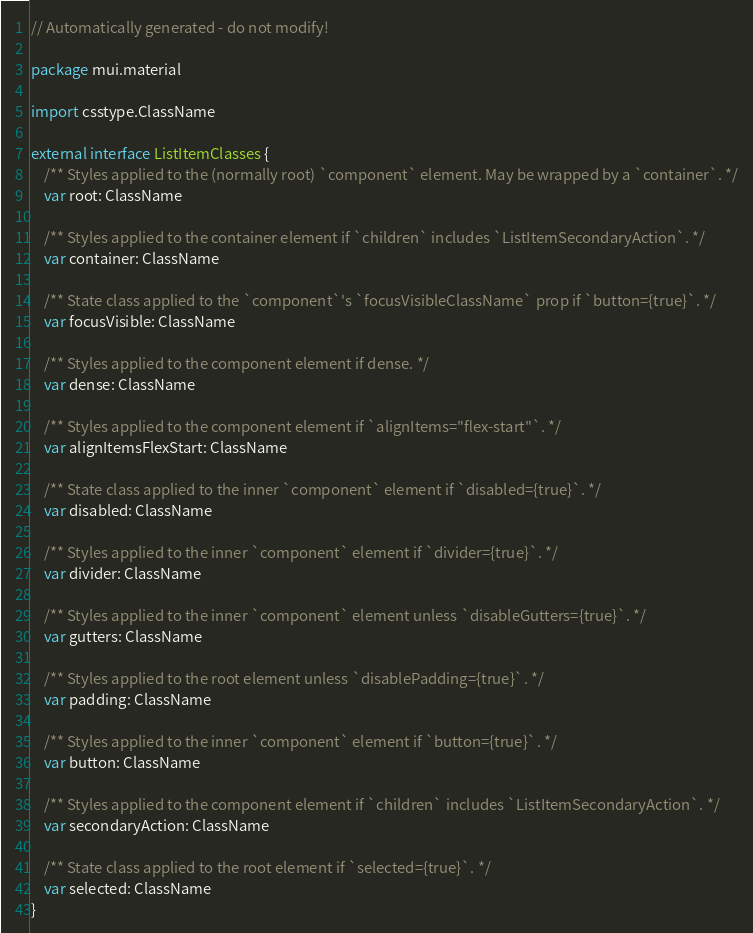Convert code to text. <code><loc_0><loc_0><loc_500><loc_500><_Kotlin_>// Automatically generated - do not modify!

package mui.material

import csstype.ClassName

external interface ListItemClasses {
    /** Styles applied to the (normally root) `component` element. May be wrapped by a `container`. */
    var root: ClassName

    /** Styles applied to the container element if `children` includes `ListItemSecondaryAction`. */
    var container: ClassName

    /** State class applied to the `component`'s `focusVisibleClassName` prop if `button={true}`. */
    var focusVisible: ClassName

    /** Styles applied to the component element if dense. */
    var dense: ClassName

    /** Styles applied to the component element if `alignItems="flex-start"`. */
    var alignItemsFlexStart: ClassName

    /** State class applied to the inner `component` element if `disabled={true}`. */
    var disabled: ClassName

    /** Styles applied to the inner `component` element if `divider={true}`. */
    var divider: ClassName

    /** Styles applied to the inner `component` element unless `disableGutters={true}`. */
    var gutters: ClassName

    /** Styles applied to the root element unless `disablePadding={true}`. */
    var padding: ClassName

    /** Styles applied to the inner `component` element if `button={true}`. */
    var button: ClassName

    /** Styles applied to the component element if `children` includes `ListItemSecondaryAction`. */
    var secondaryAction: ClassName

    /** State class applied to the root element if `selected={true}`. */
    var selected: ClassName
}
</code> 